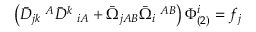Convert formula to latex. <formula><loc_0><loc_0><loc_500><loc_500>\left ( \bar { D } _ { j k } \, ^ { A } \bar { D } ^ { k } \, _ { i A } + \bar { \Omega } _ { j A B } \bar { \Omega } _ { i } \, ^ { A B } \right ) \Phi _ { ( 2 ) } ^ { i } = f _ { j }</formula> 